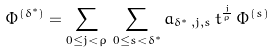Convert formula to latex. <formula><loc_0><loc_0><loc_500><loc_500>\Phi ^ { ( \delta ^ { \ast } ) } = \sum _ { 0 \leq j < \rho } \, \sum _ { 0 \leq s < \delta ^ { \ast } } a _ { \delta ^ { \ast } \, , j , s } \, t ^ { \frac { j } { \rho } } \, \Phi ^ { ( s ) }</formula> 